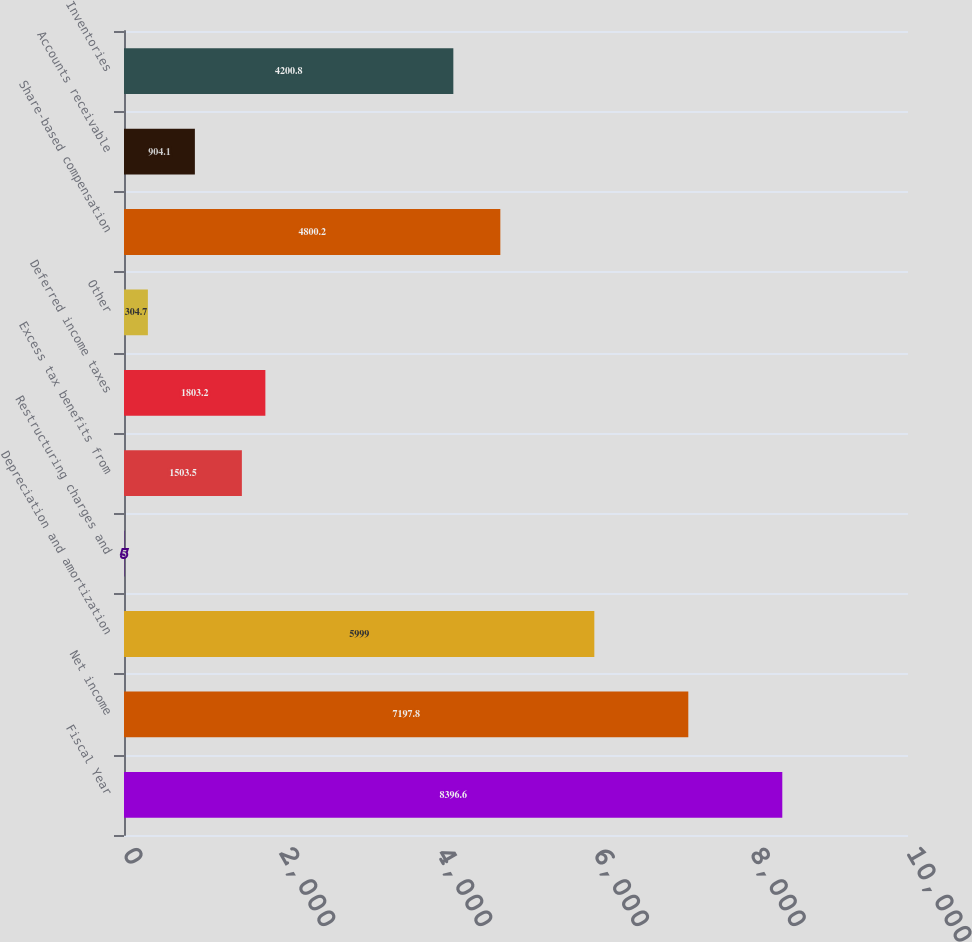Convert chart to OTSL. <chart><loc_0><loc_0><loc_500><loc_500><bar_chart><fcel>Fiscal Year<fcel>Net income<fcel>Depreciation and amortization<fcel>Restructuring charges and<fcel>Excess tax benefits from<fcel>Deferred income taxes<fcel>Other<fcel>Share-based compensation<fcel>Accounts receivable<fcel>Inventories<nl><fcel>8396.6<fcel>7197.8<fcel>5999<fcel>5<fcel>1503.5<fcel>1803.2<fcel>304.7<fcel>4800.2<fcel>904.1<fcel>4200.8<nl></chart> 